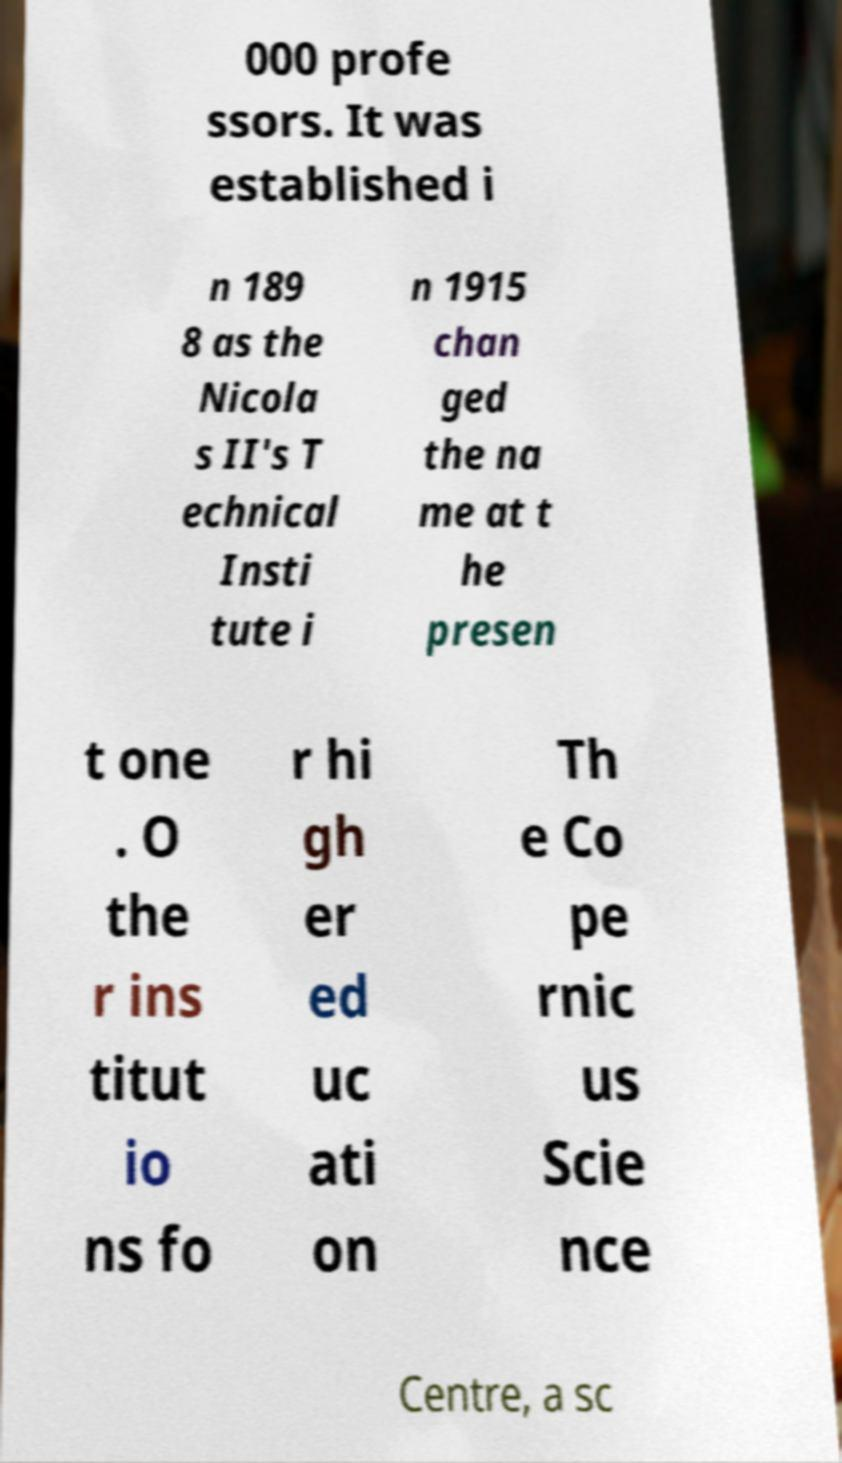Can you accurately transcribe the text from the provided image for me? 000 profe ssors. It was established i n 189 8 as the Nicola s II's T echnical Insti tute i n 1915 chan ged the na me at t he presen t one . O the r ins titut io ns fo r hi gh er ed uc ati on Th e Co pe rnic us Scie nce Centre, a sc 